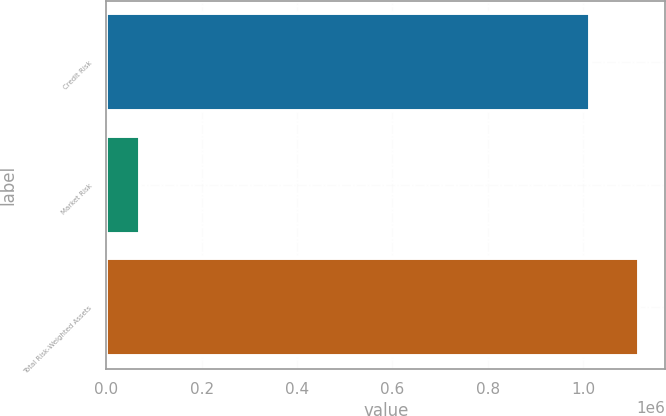Convert chart. <chart><loc_0><loc_0><loc_500><loc_500><bar_chart><fcel>Credit Risk<fcel>Market Risk<fcel>Total Risk-Weighted Assets<nl><fcel>1.01507e+06<fcel>71029<fcel>1.11658e+06<nl></chart> 